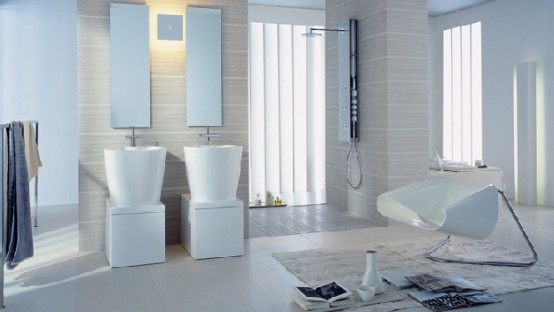Describe the objects in this image and their specific colors. I can see sink in gray, darkgray, and lightgray tones, sink in gray, darkgray, and lightgray tones, book in gray, darkgray, and black tones, book in gray, darkgray, and black tones, and bottle in gray and darkgray tones in this image. 